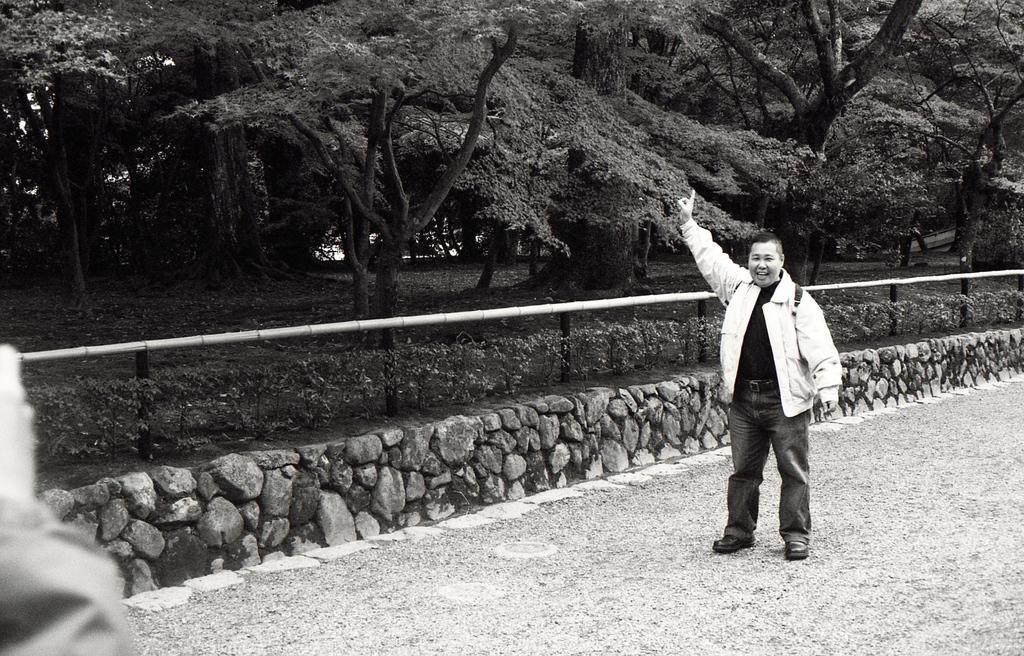What is the main subject of the image? There is a person standing in the image. What can be seen in the background of the image? The background of the image includes fencing and trees. What is the color scheme of the image? The image is in black and white. What type of decision is the person making in the image? There is no indication in the image that the person is making a decision, so it cannot be determined from the picture. 